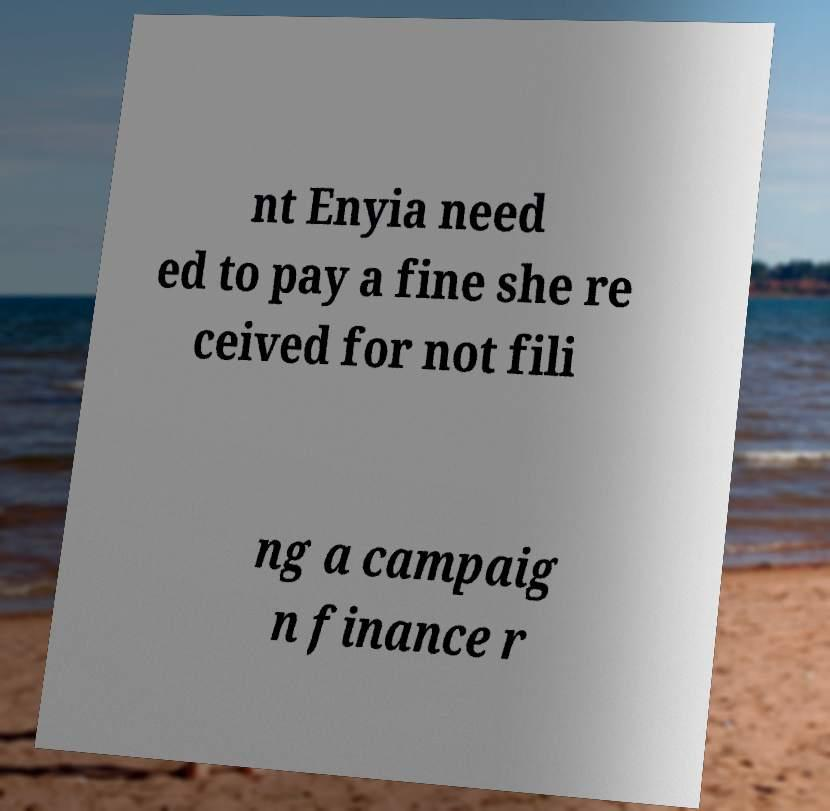Can you accurately transcribe the text from the provided image for me? nt Enyia need ed to pay a fine she re ceived for not fili ng a campaig n finance r 